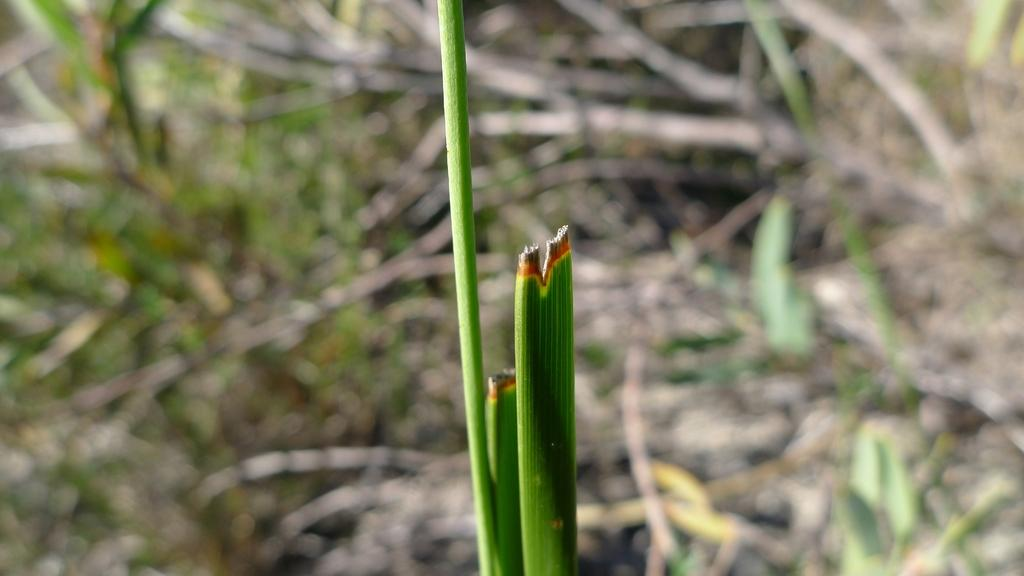What type of vegetation is present in the image? There is grass in the image. What color is the background of the grass? The background of the grass is blue. Is there a wrench visible in the image? No, there is no wrench present in the image. Is the grass being affected by a rainstorm in the image? No, there is no rainstorm depicted in the image. 